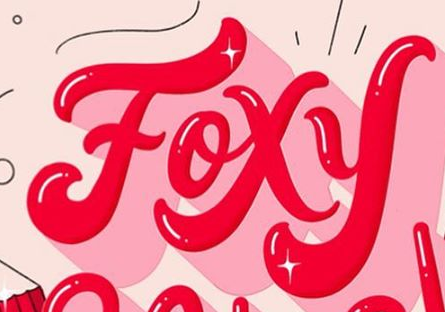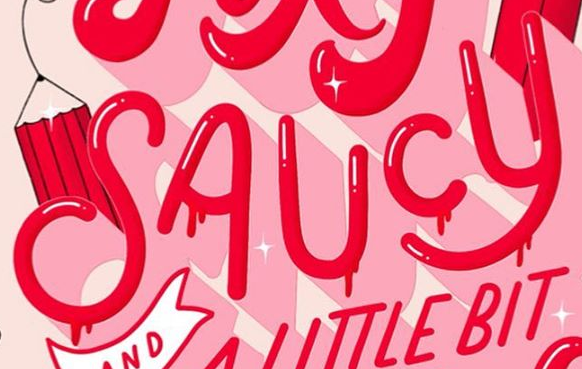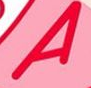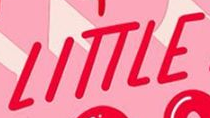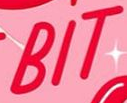What text appears in these images from left to right, separated by a semicolon? Foxy; SAUCY; A; LITTLE; BIT 